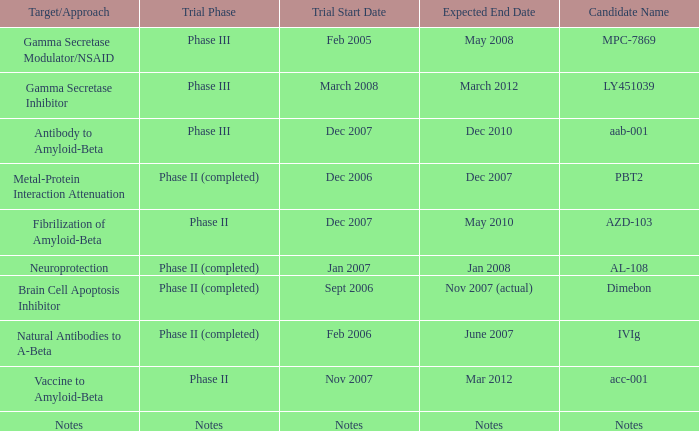What is Expected End Date, when Trial Start Date is Nov 2007? Mar 2012. 